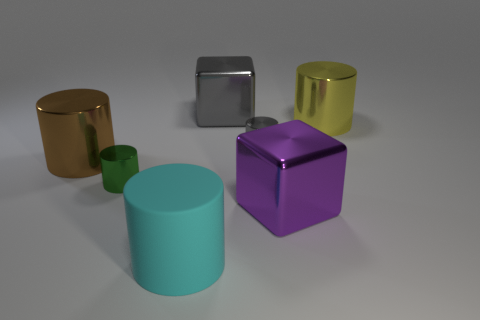There is a large cyan matte cylinder; how many gray cylinders are on the left side of it?
Your answer should be compact. 0. Are the small green object and the yellow cylinder made of the same material?
Ensure brevity in your answer.  Yes. How many large metallic things are right of the large brown metal cylinder and in front of the large gray metallic block?
Give a very brief answer. 2. What number of blue objects are metallic blocks or tiny metal objects?
Provide a short and direct response. 0. The purple shiny cube has what size?
Provide a short and direct response. Large. How many rubber things are small objects or cubes?
Offer a terse response. 0. Is the number of green shiny cylinders less than the number of tiny blue shiny things?
Give a very brief answer. No. How many other objects are the same material as the small green cylinder?
Keep it short and to the point. 5. There is a rubber thing that is the same shape as the green shiny object; what is its size?
Your answer should be very brief. Large. Does the tiny cylinder that is left of the cyan rubber object have the same material as the cylinder that is in front of the small green cylinder?
Make the answer very short. No. 